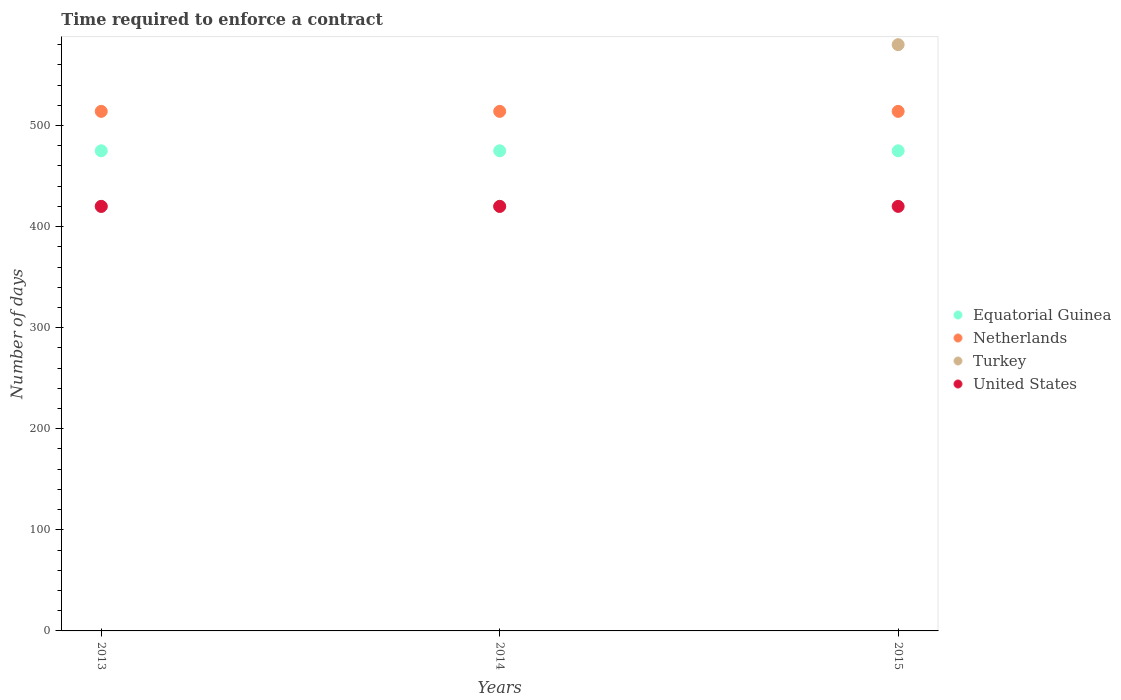How many different coloured dotlines are there?
Your answer should be very brief. 4. What is the number of days required to enforce a contract in Turkey in 2013?
Your answer should be compact. 420. Across all years, what is the maximum number of days required to enforce a contract in Equatorial Guinea?
Ensure brevity in your answer.  475. Across all years, what is the minimum number of days required to enforce a contract in Netherlands?
Offer a terse response. 514. In which year was the number of days required to enforce a contract in Turkey maximum?
Your response must be concise. 2015. In which year was the number of days required to enforce a contract in Netherlands minimum?
Provide a short and direct response. 2013. What is the total number of days required to enforce a contract in United States in the graph?
Provide a short and direct response. 1260. What is the difference between the number of days required to enforce a contract in United States in 2013 and that in 2014?
Your answer should be compact. 0. What is the difference between the number of days required to enforce a contract in Turkey in 2015 and the number of days required to enforce a contract in Netherlands in 2014?
Your answer should be compact. 66. What is the average number of days required to enforce a contract in Equatorial Guinea per year?
Provide a short and direct response. 475. In how many years, is the number of days required to enforce a contract in Netherlands greater than 120 days?
Your answer should be very brief. 3. Is the number of days required to enforce a contract in Turkey in 2014 less than that in 2015?
Make the answer very short. Yes. What is the difference between the highest and the second highest number of days required to enforce a contract in United States?
Give a very brief answer. 0. What is the difference between the highest and the lowest number of days required to enforce a contract in Netherlands?
Provide a short and direct response. 0. Is the sum of the number of days required to enforce a contract in Turkey in 2014 and 2015 greater than the maximum number of days required to enforce a contract in Equatorial Guinea across all years?
Ensure brevity in your answer.  Yes. Is it the case that in every year, the sum of the number of days required to enforce a contract in United States and number of days required to enforce a contract in Equatorial Guinea  is greater than the sum of number of days required to enforce a contract in Netherlands and number of days required to enforce a contract in Turkey?
Keep it short and to the point. Yes. Is it the case that in every year, the sum of the number of days required to enforce a contract in United States and number of days required to enforce a contract in Turkey  is greater than the number of days required to enforce a contract in Netherlands?
Provide a short and direct response. Yes. Is the number of days required to enforce a contract in Netherlands strictly less than the number of days required to enforce a contract in Turkey over the years?
Provide a short and direct response. No. How many dotlines are there?
Ensure brevity in your answer.  4. What is the difference between two consecutive major ticks on the Y-axis?
Provide a short and direct response. 100. Are the values on the major ticks of Y-axis written in scientific E-notation?
Your answer should be very brief. No. Does the graph contain grids?
Your answer should be very brief. No. How many legend labels are there?
Your answer should be compact. 4. How are the legend labels stacked?
Provide a succinct answer. Vertical. What is the title of the graph?
Your answer should be very brief. Time required to enforce a contract. Does "Burkina Faso" appear as one of the legend labels in the graph?
Offer a terse response. No. What is the label or title of the X-axis?
Your response must be concise. Years. What is the label or title of the Y-axis?
Your answer should be very brief. Number of days. What is the Number of days of Equatorial Guinea in 2013?
Offer a terse response. 475. What is the Number of days of Netherlands in 2013?
Your response must be concise. 514. What is the Number of days in Turkey in 2013?
Provide a succinct answer. 420. What is the Number of days of United States in 2013?
Provide a succinct answer. 420. What is the Number of days of Equatorial Guinea in 2014?
Your answer should be compact. 475. What is the Number of days of Netherlands in 2014?
Give a very brief answer. 514. What is the Number of days of Turkey in 2014?
Provide a short and direct response. 420. What is the Number of days in United States in 2014?
Provide a succinct answer. 420. What is the Number of days in Equatorial Guinea in 2015?
Keep it short and to the point. 475. What is the Number of days of Netherlands in 2015?
Make the answer very short. 514. What is the Number of days in Turkey in 2015?
Your answer should be compact. 580. What is the Number of days in United States in 2015?
Provide a short and direct response. 420. Across all years, what is the maximum Number of days in Equatorial Guinea?
Your answer should be very brief. 475. Across all years, what is the maximum Number of days in Netherlands?
Offer a terse response. 514. Across all years, what is the maximum Number of days of Turkey?
Your answer should be very brief. 580. Across all years, what is the maximum Number of days of United States?
Provide a short and direct response. 420. Across all years, what is the minimum Number of days in Equatorial Guinea?
Offer a terse response. 475. Across all years, what is the minimum Number of days of Netherlands?
Offer a very short reply. 514. Across all years, what is the minimum Number of days in Turkey?
Ensure brevity in your answer.  420. Across all years, what is the minimum Number of days in United States?
Offer a very short reply. 420. What is the total Number of days in Equatorial Guinea in the graph?
Your answer should be compact. 1425. What is the total Number of days in Netherlands in the graph?
Keep it short and to the point. 1542. What is the total Number of days in Turkey in the graph?
Provide a succinct answer. 1420. What is the total Number of days of United States in the graph?
Keep it short and to the point. 1260. What is the difference between the Number of days of Equatorial Guinea in 2013 and that in 2014?
Keep it short and to the point. 0. What is the difference between the Number of days of Netherlands in 2013 and that in 2014?
Give a very brief answer. 0. What is the difference between the Number of days in United States in 2013 and that in 2014?
Your answer should be very brief. 0. What is the difference between the Number of days in Netherlands in 2013 and that in 2015?
Make the answer very short. 0. What is the difference between the Number of days of Turkey in 2013 and that in 2015?
Your answer should be very brief. -160. What is the difference between the Number of days in Equatorial Guinea in 2014 and that in 2015?
Ensure brevity in your answer.  0. What is the difference between the Number of days in Turkey in 2014 and that in 2015?
Your answer should be very brief. -160. What is the difference between the Number of days in United States in 2014 and that in 2015?
Offer a terse response. 0. What is the difference between the Number of days in Equatorial Guinea in 2013 and the Number of days in Netherlands in 2014?
Provide a short and direct response. -39. What is the difference between the Number of days in Netherlands in 2013 and the Number of days in Turkey in 2014?
Your response must be concise. 94. What is the difference between the Number of days in Netherlands in 2013 and the Number of days in United States in 2014?
Offer a terse response. 94. What is the difference between the Number of days of Turkey in 2013 and the Number of days of United States in 2014?
Keep it short and to the point. 0. What is the difference between the Number of days of Equatorial Guinea in 2013 and the Number of days of Netherlands in 2015?
Give a very brief answer. -39. What is the difference between the Number of days in Equatorial Guinea in 2013 and the Number of days in Turkey in 2015?
Ensure brevity in your answer.  -105. What is the difference between the Number of days in Netherlands in 2013 and the Number of days in Turkey in 2015?
Provide a short and direct response. -66. What is the difference between the Number of days in Netherlands in 2013 and the Number of days in United States in 2015?
Ensure brevity in your answer.  94. What is the difference between the Number of days of Turkey in 2013 and the Number of days of United States in 2015?
Offer a very short reply. 0. What is the difference between the Number of days in Equatorial Guinea in 2014 and the Number of days in Netherlands in 2015?
Give a very brief answer. -39. What is the difference between the Number of days in Equatorial Guinea in 2014 and the Number of days in Turkey in 2015?
Offer a terse response. -105. What is the difference between the Number of days of Netherlands in 2014 and the Number of days of Turkey in 2015?
Make the answer very short. -66. What is the difference between the Number of days in Netherlands in 2014 and the Number of days in United States in 2015?
Offer a very short reply. 94. What is the average Number of days of Equatorial Guinea per year?
Offer a terse response. 475. What is the average Number of days in Netherlands per year?
Offer a terse response. 514. What is the average Number of days in Turkey per year?
Offer a terse response. 473.33. What is the average Number of days in United States per year?
Provide a short and direct response. 420. In the year 2013, what is the difference between the Number of days of Equatorial Guinea and Number of days of Netherlands?
Provide a short and direct response. -39. In the year 2013, what is the difference between the Number of days of Equatorial Guinea and Number of days of Turkey?
Ensure brevity in your answer.  55. In the year 2013, what is the difference between the Number of days of Netherlands and Number of days of Turkey?
Offer a terse response. 94. In the year 2013, what is the difference between the Number of days of Netherlands and Number of days of United States?
Your answer should be very brief. 94. In the year 2014, what is the difference between the Number of days of Equatorial Guinea and Number of days of Netherlands?
Your answer should be very brief. -39. In the year 2014, what is the difference between the Number of days of Equatorial Guinea and Number of days of Turkey?
Ensure brevity in your answer.  55. In the year 2014, what is the difference between the Number of days in Netherlands and Number of days in Turkey?
Your answer should be very brief. 94. In the year 2014, what is the difference between the Number of days in Netherlands and Number of days in United States?
Offer a very short reply. 94. In the year 2014, what is the difference between the Number of days in Turkey and Number of days in United States?
Ensure brevity in your answer.  0. In the year 2015, what is the difference between the Number of days in Equatorial Guinea and Number of days in Netherlands?
Provide a succinct answer. -39. In the year 2015, what is the difference between the Number of days of Equatorial Guinea and Number of days of Turkey?
Keep it short and to the point. -105. In the year 2015, what is the difference between the Number of days of Equatorial Guinea and Number of days of United States?
Offer a very short reply. 55. In the year 2015, what is the difference between the Number of days of Netherlands and Number of days of Turkey?
Your response must be concise. -66. In the year 2015, what is the difference between the Number of days of Netherlands and Number of days of United States?
Your answer should be very brief. 94. In the year 2015, what is the difference between the Number of days of Turkey and Number of days of United States?
Offer a terse response. 160. What is the ratio of the Number of days of Equatorial Guinea in 2013 to that in 2014?
Offer a very short reply. 1. What is the ratio of the Number of days in Turkey in 2013 to that in 2014?
Ensure brevity in your answer.  1. What is the ratio of the Number of days in Equatorial Guinea in 2013 to that in 2015?
Provide a short and direct response. 1. What is the ratio of the Number of days of Turkey in 2013 to that in 2015?
Provide a short and direct response. 0.72. What is the ratio of the Number of days of United States in 2013 to that in 2015?
Make the answer very short. 1. What is the ratio of the Number of days of Equatorial Guinea in 2014 to that in 2015?
Provide a short and direct response. 1. What is the ratio of the Number of days in Turkey in 2014 to that in 2015?
Your answer should be very brief. 0.72. What is the difference between the highest and the second highest Number of days in Netherlands?
Offer a terse response. 0. What is the difference between the highest and the second highest Number of days in Turkey?
Your answer should be compact. 160. What is the difference between the highest and the lowest Number of days of Netherlands?
Offer a terse response. 0. What is the difference between the highest and the lowest Number of days of Turkey?
Keep it short and to the point. 160. 